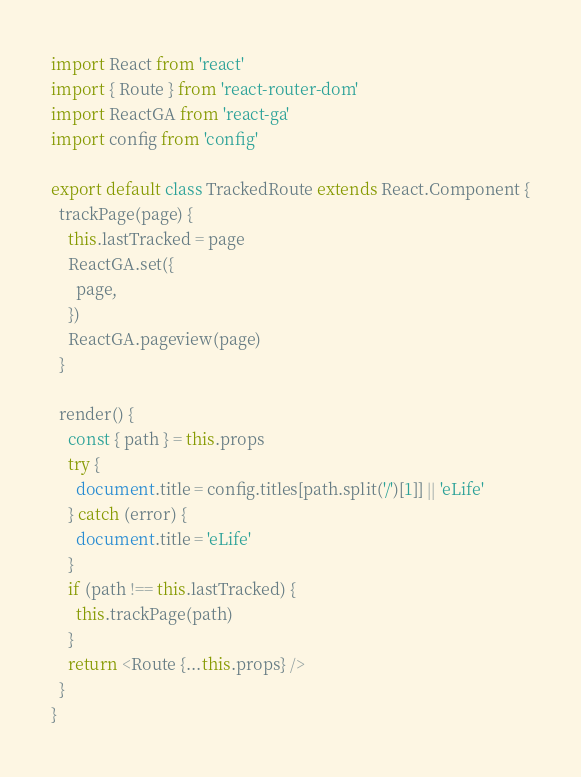Convert code to text. <code><loc_0><loc_0><loc_500><loc_500><_JavaScript_>import React from 'react'
import { Route } from 'react-router-dom'
import ReactGA from 'react-ga'
import config from 'config'

export default class TrackedRoute extends React.Component {
  trackPage(page) {
    this.lastTracked = page
    ReactGA.set({
      page,
    })
    ReactGA.pageview(page)
  }

  render() {
    const { path } = this.props
    try {
      document.title = config.titles[path.split('/')[1]] || 'eLife'
    } catch (error) {
      document.title = 'eLife'
    }
    if (path !== this.lastTracked) {
      this.trackPage(path)
    }
    return <Route {...this.props} />
  }
}
</code> 